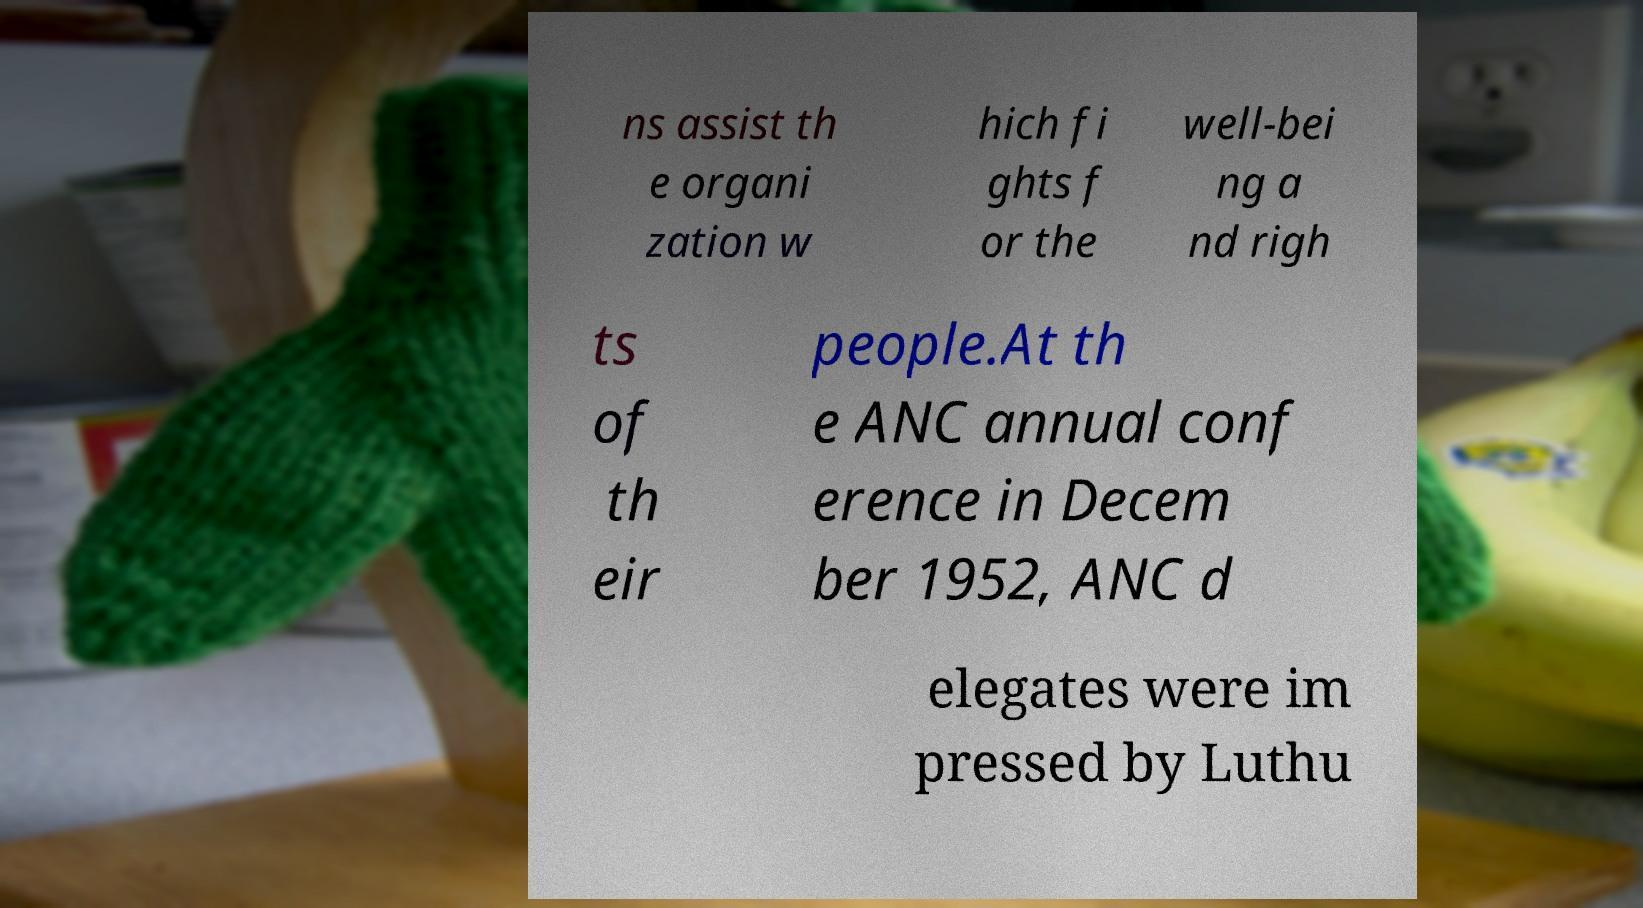For documentation purposes, I need the text within this image transcribed. Could you provide that? ns assist th e organi zation w hich fi ghts f or the well-bei ng a nd righ ts of th eir people.At th e ANC annual conf erence in Decem ber 1952, ANC d elegates were im pressed by Luthu 